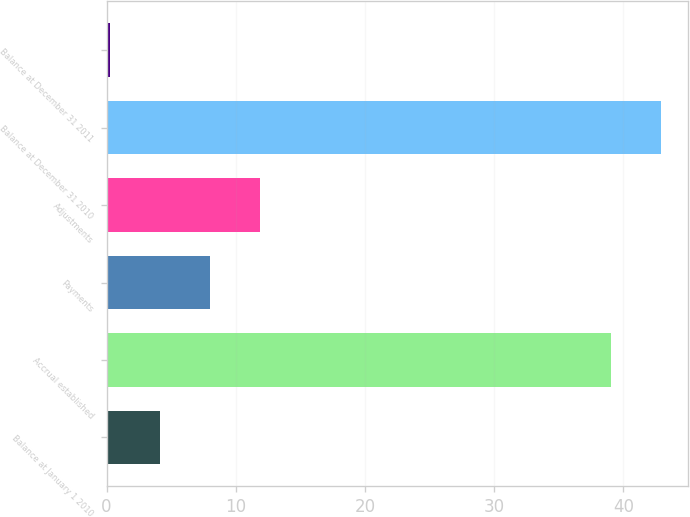Convert chart. <chart><loc_0><loc_0><loc_500><loc_500><bar_chart><fcel>Balance at January 1 2010<fcel>Accrual established<fcel>Payments<fcel>Adjustments<fcel>Balance at December 31 2010<fcel>Balance at December 31 2011<nl><fcel>4.13<fcel>39<fcel>8<fcel>11.87<fcel>42.87<fcel>0.26<nl></chart> 